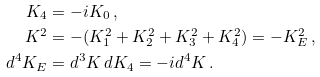Convert formula to latex. <formula><loc_0><loc_0><loc_500><loc_500>K _ { 4 } & = - i K _ { 0 } \, , \\ K ^ { 2 } & = - ( K _ { 1 } ^ { 2 } + K _ { 2 } ^ { 2 } + K _ { 3 } ^ { 2 } + K _ { 4 } ^ { 2 } ) = - K _ { E } ^ { 2 } \, , \\ d ^ { 4 } K _ { E } & = d ^ { 3 } K \, d K _ { 4 } = - i d ^ { 4 } K \, .</formula> 